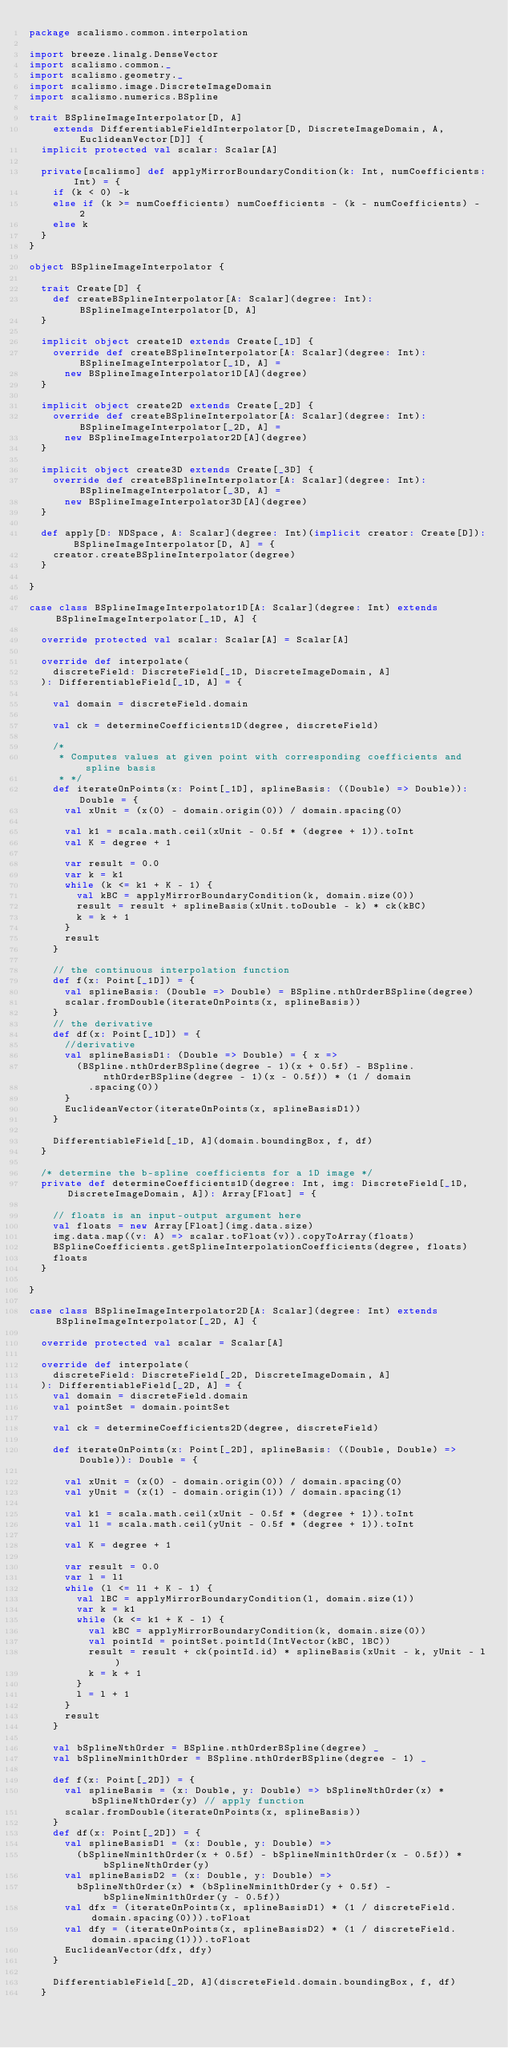Convert code to text. <code><loc_0><loc_0><loc_500><loc_500><_Scala_>package scalismo.common.interpolation

import breeze.linalg.DenseVector
import scalismo.common._
import scalismo.geometry._
import scalismo.image.DiscreteImageDomain
import scalismo.numerics.BSpline

trait BSplineImageInterpolator[D, A]
    extends DifferentiableFieldInterpolator[D, DiscreteImageDomain, A, EuclideanVector[D]] {
  implicit protected val scalar: Scalar[A]

  private[scalismo] def applyMirrorBoundaryCondition(k: Int, numCoefficients: Int) = {
    if (k < 0) -k
    else if (k >= numCoefficients) numCoefficients - (k - numCoefficients) - 2
    else k
  }
}

object BSplineImageInterpolator {

  trait Create[D] {
    def createBSplineInterpolator[A: Scalar](degree: Int): BSplineImageInterpolator[D, A]
  }

  implicit object create1D extends Create[_1D] {
    override def createBSplineInterpolator[A: Scalar](degree: Int): BSplineImageInterpolator[_1D, A] =
      new BSplineImageInterpolator1D[A](degree)
  }

  implicit object create2D extends Create[_2D] {
    override def createBSplineInterpolator[A: Scalar](degree: Int): BSplineImageInterpolator[_2D, A] =
      new BSplineImageInterpolator2D[A](degree)
  }

  implicit object create3D extends Create[_3D] {
    override def createBSplineInterpolator[A: Scalar](degree: Int): BSplineImageInterpolator[_3D, A] =
      new BSplineImageInterpolator3D[A](degree)
  }

  def apply[D: NDSpace, A: Scalar](degree: Int)(implicit creator: Create[D]): BSplineImageInterpolator[D, A] = {
    creator.createBSplineInterpolator(degree)
  }

}

case class BSplineImageInterpolator1D[A: Scalar](degree: Int) extends BSplineImageInterpolator[_1D, A] {

  override protected val scalar: Scalar[A] = Scalar[A]

  override def interpolate(
    discreteField: DiscreteField[_1D, DiscreteImageDomain, A]
  ): DifferentiableField[_1D, A] = {

    val domain = discreteField.domain

    val ck = determineCoefficients1D(degree, discreteField)

    /*
     * Computes values at given point with corresponding coefficients and spline basis
     * */
    def iterateOnPoints(x: Point[_1D], splineBasis: ((Double) => Double)): Double = {
      val xUnit = (x(0) - domain.origin(0)) / domain.spacing(0)

      val k1 = scala.math.ceil(xUnit - 0.5f * (degree + 1)).toInt
      val K = degree + 1

      var result = 0.0
      var k = k1
      while (k <= k1 + K - 1) {
        val kBC = applyMirrorBoundaryCondition(k, domain.size(0))
        result = result + splineBasis(xUnit.toDouble - k) * ck(kBC)
        k = k + 1
      }
      result
    }

    // the continuous interpolation function
    def f(x: Point[_1D]) = {
      val splineBasis: (Double => Double) = BSpline.nthOrderBSpline(degree)
      scalar.fromDouble(iterateOnPoints(x, splineBasis))
    }
    // the derivative
    def df(x: Point[_1D]) = {
      //derivative
      val splineBasisD1: (Double => Double) = { x =>
        (BSpline.nthOrderBSpline(degree - 1)(x + 0.5f) - BSpline.nthOrderBSpline(degree - 1)(x - 0.5f)) * (1 / domain
          .spacing(0))
      }
      EuclideanVector(iterateOnPoints(x, splineBasisD1))
    }

    DifferentiableField[_1D, A](domain.boundingBox, f, df)
  }

  /* determine the b-spline coefficients for a 1D image */
  private def determineCoefficients1D(degree: Int, img: DiscreteField[_1D, DiscreteImageDomain, A]): Array[Float] = {

    // floats is an input-output argument here
    val floats = new Array[Float](img.data.size)
    img.data.map((v: A) => scalar.toFloat(v)).copyToArray(floats)
    BSplineCoefficients.getSplineInterpolationCoefficients(degree, floats)
    floats
  }

}

case class BSplineImageInterpolator2D[A: Scalar](degree: Int) extends BSplineImageInterpolator[_2D, A] {

  override protected val scalar = Scalar[A]

  override def interpolate(
    discreteField: DiscreteField[_2D, DiscreteImageDomain, A]
  ): DifferentiableField[_2D, A] = {
    val domain = discreteField.domain
    val pointSet = domain.pointSet

    val ck = determineCoefficients2D(degree, discreteField)

    def iterateOnPoints(x: Point[_2D], splineBasis: ((Double, Double) => Double)): Double = {

      val xUnit = (x(0) - domain.origin(0)) / domain.spacing(0)
      val yUnit = (x(1) - domain.origin(1)) / domain.spacing(1)

      val k1 = scala.math.ceil(xUnit - 0.5f * (degree + 1)).toInt
      val l1 = scala.math.ceil(yUnit - 0.5f * (degree + 1)).toInt

      val K = degree + 1

      var result = 0.0
      var l = l1
      while (l <= l1 + K - 1) {
        val lBC = applyMirrorBoundaryCondition(l, domain.size(1))
        var k = k1
        while (k <= k1 + K - 1) {
          val kBC = applyMirrorBoundaryCondition(k, domain.size(0))
          val pointId = pointSet.pointId(IntVector(kBC, lBC))
          result = result + ck(pointId.id) * splineBasis(xUnit - k, yUnit - l)
          k = k + 1
        }
        l = l + 1
      }
      result
    }

    val bSplineNthOrder = BSpline.nthOrderBSpline(degree) _
    val bSplineNmin1thOrder = BSpline.nthOrderBSpline(degree - 1) _

    def f(x: Point[_2D]) = {
      val splineBasis = (x: Double, y: Double) => bSplineNthOrder(x) * bSplineNthOrder(y) // apply function
      scalar.fromDouble(iterateOnPoints(x, splineBasis))
    }
    def df(x: Point[_2D]) = {
      val splineBasisD1 = (x: Double, y: Double) =>
        (bSplineNmin1thOrder(x + 0.5f) - bSplineNmin1thOrder(x - 0.5f)) * bSplineNthOrder(y)
      val splineBasisD2 = (x: Double, y: Double) =>
        bSplineNthOrder(x) * (bSplineNmin1thOrder(y + 0.5f) - bSplineNmin1thOrder(y - 0.5f))
      val dfx = (iterateOnPoints(x, splineBasisD1) * (1 / discreteField.domain.spacing(0))).toFloat
      val dfy = (iterateOnPoints(x, splineBasisD2) * (1 / discreteField.domain.spacing(1))).toFloat
      EuclideanVector(dfx, dfy)
    }

    DifferentiableField[_2D, A](discreteField.domain.boundingBox, f, df)
  }
</code> 